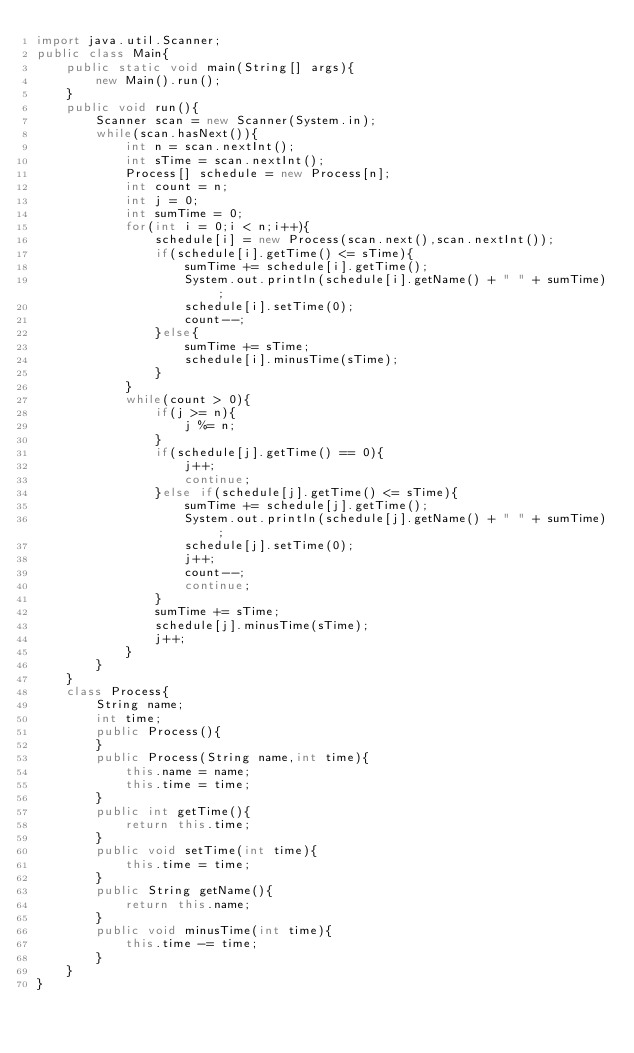<code> <loc_0><loc_0><loc_500><loc_500><_Java_>import java.util.Scanner;
public class Main{
	public static void main(String[] args){
		new Main().run();
	}
	public void run(){
		Scanner scan = new Scanner(System.in);
		while(scan.hasNext()){
			int n = scan.nextInt();
			int sTime = scan.nextInt();
			Process[] schedule = new Process[n];
			int count = n;
			int j = 0;
			int sumTime = 0;
			for(int i = 0;i < n;i++){
				schedule[i] = new Process(scan.next(),scan.nextInt());
				if(schedule[i].getTime() <= sTime){
					sumTime += schedule[i].getTime();
					System.out.println(schedule[i].getName() + " " + sumTime);
					schedule[i].setTime(0);
					count--;
				}else{
					sumTime += sTime;
					schedule[i].minusTime(sTime);
				}
			}
			while(count > 0){
				if(j >= n){
					j %= n;
				}
				if(schedule[j].getTime() == 0){
					j++;
					continue;
				}else if(schedule[j].getTime() <= sTime){
					sumTime += schedule[j].getTime();
					System.out.println(schedule[j].getName() + " " + sumTime);
					schedule[j].setTime(0);
					j++;
					count--;
					continue;
				}
				sumTime += sTime;
				schedule[j].minusTime(sTime);
				j++;
			}
		}
	}
	class Process{
		String name;
		int time;
		public Process(){
		}
		public Process(String name,int time){
			this.name = name;
			this.time = time;
		}
		public int getTime(){
			return this.time;
		}
		public void setTime(int time){
			this.time = time;
		}
		public String getName(){
			return this.name;
		}
		public void minusTime(int time){
			this.time -= time;
		}
	}
}</code> 